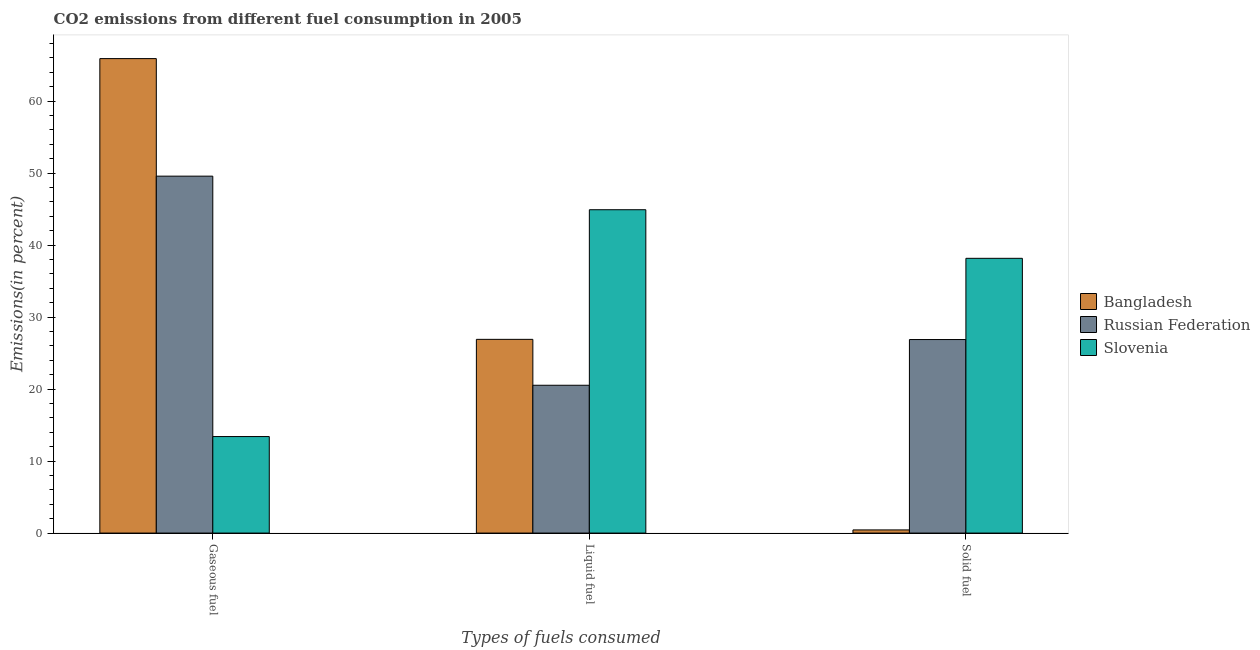How many different coloured bars are there?
Provide a succinct answer. 3. How many groups of bars are there?
Provide a succinct answer. 3. Are the number of bars per tick equal to the number of legend labels?
Keep it short and to the point. Yes. Are the number of bars on each tick of the X-axis equal?
Your answer should be compact. Yes. How many bars are there on the 3rd tick from the left?
Your answer should be compact. 3. How many bars are there on the 1st tick from the right?
Ensure brevity in your answer.  3. What is the label of the 1st group of bars from the left?
Provide a succinct answer. Gaseous fuel. What is the percentage of solid fuel emission in Bangladesh?
Your answer should be very brief. 0.44. Across all countries, what is the maximum percentage of gaseous fuel emission?
Keep it short and to the point. 65.89. Across all countries, what is the minimum percentage of liquid fuel emission?
Offer a terse response. 20.53. In which country was the percentage of liquid fuel emission maximum?
Ensure brevity in your answer.  Slovenia. In which country was the percentage of gaseous fuel emission minimum?
Offer a very short reply. Slovenia. What is the total percentage of liquid fuel emission in the graph?
Your answer should be compact. 92.33. What is the difference between the percentage of gaseous fuel emission in Slovenia and that in Russian Federation?
Keep it short and to the point. -36.16. What is the difference between the percentage of liquid fuel emission in Slovenia and the percentage of solid fuel emission in Russian Federation?
Offer a very short reply. 18.03. What is the average percentage of solid fuel emission per country?
Make the answer very short. 21.82. What is the difference between the percentage of gaseous fuel emission and percentage of liquid fuel emission in Slovenia?
Offer a terse response. -31.5. What is the ratio of the percentage of gaseous fuel emission in Russian Federation to that in Slovenia?
Provide a succinct answer. 3.7. What is the difference between the highest and the second highest percentage of liquid fuel emission?
Give a very brief answer. 18. What is the difference between the highest and the lowest percentage of solid fuel emission?
Ensure brevity in your answer.  37.72. Is the sum of the percentage of gaseous fuel emission in Russian Federation and Slovenia greater than the maximum percentage of solid fuel emission across all countries?
Keep it short and to the point. Yes. What does the 3rd bar from the left in Solid fuel represents?
Your answer should be very brief. Slovenia. What does the 3rd bar from the right in Gaseous fuel represents?
Ensure brevity in your answer.  Bangladesh. Are all the bars in the graph horizontal?
Make the answer very short. No. How many countries are there in the graph?
Your answer should be very brief. 3. What is the difference between two consecutive major ticks on the Y-axis?
Keep it short and to the point. 10. Does the graph contain grids?
Give a very brief answer. No. Where does the legend appear in the graph?
Your answer should be very brief. Center right. What is the title of the graph?
Your response must be concise. CO2 emissions from different fuel consumption in 2005. What is the label or title of the X-axis?
Ensure brevity in your answer.  Types of fuels consumed. What is the label or title of the Y-axis?
Give a very brief answer. Emissions(in percent). What is the Emissions(in percent) of Bangladesh in Gaseous fuel?
Provide a succinct answer. 65.89. What is the Emissions(in percent) of Russian Federation in Gaseous fuel?
Ensure brevity in your answer.  49.57. What is the Emissions(in percent) of Slovenia in Gaseous fuel?
Offer a terse response. 13.4. What is the Emissions(in percent) in Bangladesh in Liquid fuel?
Make the answer very short. 26.9. What is the Emissions(in percent) of Russian Federation in Liquid fuel?
Make the answer very short. 20.53. What is the Emissions(in percent) in Slovenia in Liquid fuel?
Your response must be concise. 44.9. What is the Emissions(in percent) in Bangladesh in Solid fuel?
Keep it short and to the point. 0.44. What is the Emissions(in percent) in Russian Federation in Solid fuel?
Provide a succinct answer. 26.88. What is the Emissions(in percent) of Slovenia in Solid fuel?
Your response must be concise. 38.16. Across all Types of fuels consumed, what is the maximum Emissions(in percent) in Bangladesh?
Make the answer very short. 65.89. Across all Types of fuels consumed, what is the maximum Emissions(in percent) in Russian Federation?
Provide a short and direct response. 49.57. Across all Types of fuels consumed, what is the maximum Emissions(in percent) in Slovenia?
Your response must be concise. 44.9. Across all Types of fuels consumed, what is the minimum Emissions(in percent) of Bangladesh?
Keep it short and to the point. 0.44. Across all Types of fuels consumed, what is the minimum Emissions(in percent) in Russian Federation?
Keep it short and to the point. 20.53. Across all Types of fuels consumed, what is the minimum Emissions(in percent) of Slovenia?
Ensure brevity in your answer.  13.4. What is the total Emissions(in percent) in Bangladesh in the graph?
Offer a very short reply. 93.23. What is the total Emissions(in percent) in Russian Federation in the graph?
Make the answer very short. 96.97. What is the total Emissions(in percent) of Slovenia in the graph?
Your answer should be very brief. 96.46. What is the difference between the Emissions(in percent) of Bangladesh in Gaseous fuel and that in Liquid fuel?
Offer a very short reply. 38.99. What is the difference between the Emissions(in percent) of Russian Federation in Gaseous fuel and that in Liquid fuel?
Make the answer very short. 29.04. What is the difference between the Emissions(in percent) of Slovenia in Gaseous fuel and that in Liquid fuel?
Offer a very short reply. -31.5. What is the difference between the Emissions(in percent) in Bangladesh in Gaseous fuel and that in Solid fuel?
Give a very brief answer. 65.45. What is the difference between the Emissions(in percent) in Russian Federation in Gaseous fuel and that in Solid fuel?
Your response must be concise. 22.69. What is the difference between the Emissions(in percent) in Slovenia in Gaseous fuel and that in Solid fuel?
Give a very brief answer. -24.75. What is the difference between the Emissions(in percent) in Bangladesh in Liquid fuel and that in Solid fuel?
Your answer should be very brief. 26.46. What is the difference between the Emissions(in percent) of Russian Federation in Liquid fuel and that in Solid fuel?
Your answer should be very brief. -6.35. What is the difference between the Emissions(in percent) of Slovenia in Liquid fuel and that in Solid fuel?
Give a very brief answer. 6.75. What is the difference between the Emissions(in percent) in Bangladesh in Gaseous fuel and the Emissions(in percent) in Russian Federation in Liquid fuel?
Ensure brevity in your answer.  45.36. What is the difference between the Emissions(in percent) of Bangladesh in Gaseous fuel and the Emissions(in percent) of Slovenia in Liquid fuel?
Ensure brevity in your answer.  20.99. What is the difference between the Emissions(in percent) in Russian Federation in Gaseous fuel and the Emissions(in percent) in Slovenia in Liquid fuel?
Make the answer very short. 4.66. What is the difference between the Emissions(in percent) in Bangladesh in Gaseous fuel and the Emissions(in percent) in Russian Federation in Solid fuel?
Provide a short and direct response. 39.02. What is the difference between the Emissions(in percent) in Bangladesh in Gaseous fuel and the Emissions(in percent) in Slovenia in Solid fuel?
Offer a terse response. 27.74. What is the difference between the Emissions(in percent) in Russian Federation in Gaseous fuel and the Emissions(in percent) in Slovenia in Solid fuel?
Make the answer very short. 11.41. What is the difference between the Emissions(in percent) of Bangladesh in Liquid fuel and the Emissions(in percent) of Russian Federation in Solid fuel?
Provide a short and direct response. 0.03. What is the difference between the Emissions(in percent) in Bangladesh in Liquid fuel and the Emissions(in percent) in Slovenia in Solid fuel?
Your answer should be compact. -11.25. What is the difference between the Emissions(in percent) of Russian Federation in Liquid fuel and the Emissions(in percent) of Slovenia in Solid fuel?
Offer a very short reply. -17.63. What is the average Emissions(in percent) of Bangladesh per Types of fuels consumed?
Your response must be concise. 31.08. What is the average Emissions(in percent) in Russian Federation per Types of fuels consumed?
Ensure brevity in your answer.  32.32. What is the average Emissions(in percent) of Slovenia per Types of fuels consumed?
Your answer should be compact. 32.15. What is the difference between the Emissions(in percent) in Bangladesh and Emissions(in percent) in Russian Federation in Gaseous fuel?
Offer a very short reply. 16.32. What is the difference between the Emissions(in percent) in Bangladesh and Emissions(in percent) in Slovenia in Gaseous fuel?
Provide a short and direct response. 52.49. What is the difference between the Emissions(in percent) of Russian Federation and Emissions(in percent) of Slovenia in Gaseous fuel?
Offer a terse response. 36.16. What is the difference between the Emissions(in percent) of Bangladesh and Emissions(in percent) of Russian Federation in Liquid fuel?
Make the answer very short. 6.37. What is the difference between the Emissions(in percent) of Bangladesh and Emissions(in percent) of Slovenia in Liquid fuel?
Offer a terse response. -18. What is the difference between the Emissions(in percent) of Russian Federation and Emissions(in percent) of Slovenia in Liquid fuel?
Your response must be concise. -24.38. What is the difference between the Emissions(in percent) in Bangladesh and Emissions(in percent) in Russian Federation in Solid fuel?
Offer a terse response. -26.44. What is the difference between the Emissions(in percent) in Bangladesh and Emissions(in percent) in Slovenia in Solid fuel?
Give a very brief answer. -37.72. What is the difference between the Emissions(in percent) in Russian Federation and Emissions(in percent) in Slovenia in Solid fuel?
Give a very brief answer. -11.28. What is the ratio of the Emissions(in percent) of Bangladesh in Gaseous fuel to that in Liquid fuel?
Your response must be concise. 2.45. What is the ratio of the Emissions(in percent) of Russian Federation in Gaseous fuel to that in Liquid fuel?
Your response must be concise. 2.41. What is the ratio of the Emissions(in percent) of Slovenia in Gaseous fuel to that in Liquid fuel?
Make the answer very short. 0.3. What is the ratio of the Emissions(in percent) in Bangladesh in Gaseous fuel to that in Solid fuel?
Keep it short and to the point. 149.96. What is the ratio of the Emissions(in percent) in Russian Federation in Gaseous fuel to that in Solid fuel?
Give a very brief answer. 1.84. What is the ratio of the Emissions(in percent) in Slovenia in Gaseous fuel to that in Solid fuel?
Ensure brevity in your answer.  0.35. What is the ratio of the Emissions(in percent) in Bangladesh in Liquid fuel to that in Solid fuel?
Your answer should be very brief. 61.22. What is the ratio of the Emissions(in percent) in Russian Federation in Liquid fuel to that in Solid fuel?
Ensure brevity in your answer.  0.76. What is the ratio of the Emissions(in percent) of Slovenia in Liquid fuel to that in Solid fuel?
Give a very brief answer. 1.18. What is the difference between the highest and the second highest Emissions(in percent) in Bangladesh?
Provide a short and direct response. 38.99. What is the difference between the highest and the second highest Emissions(in percent) of Russian Federation?
Provide a succinct answer. 22.69. What is the difference between the highest and the second highest Emissions(in percent) in Slovenia?
Offer a terse response. 6.75. What is the difference between the highest and the lowest Emissions(in percent) of Bangladesh?
Ensure brevity in your answer.  65.45. What is the difference between the highest and the lowest Emissions(in percent) in Russian Federation?
Provide a succinct answer. 29.04. What is the difference between the highest and the lowest Emissions(in percent) in Slovenia?
Your answer should be very brief. 31.5. 